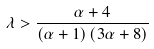<formula> <loc_0><loc_0><loc_500><loc_500>\lambda > \frac { \alpha + 4 } { \left ( \alpha + 1 \right ) \left ( 3 \alpha + 8 \right ) }</formula> 